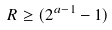Convert formula to latex. <formula><loc_0><loc_0><loc_500><loc_500>R \geq ( 2 ^ { a - 1 } - 1 )</formula> 